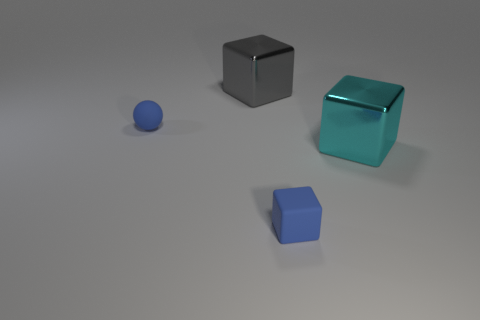Add 2 big blocks. How many objects exist? 6 Subtract all balls. How many objects are left? 3 Subtract 0 green blocks. How many objects are left? 4 Subtract all big green things. Subtract all blue blocks. How many objects are left? 3 Add 1 blocks. How many blocks are left? 4 Add 4 large cyan shiny things. How many large cyan shiny things exist? 5 